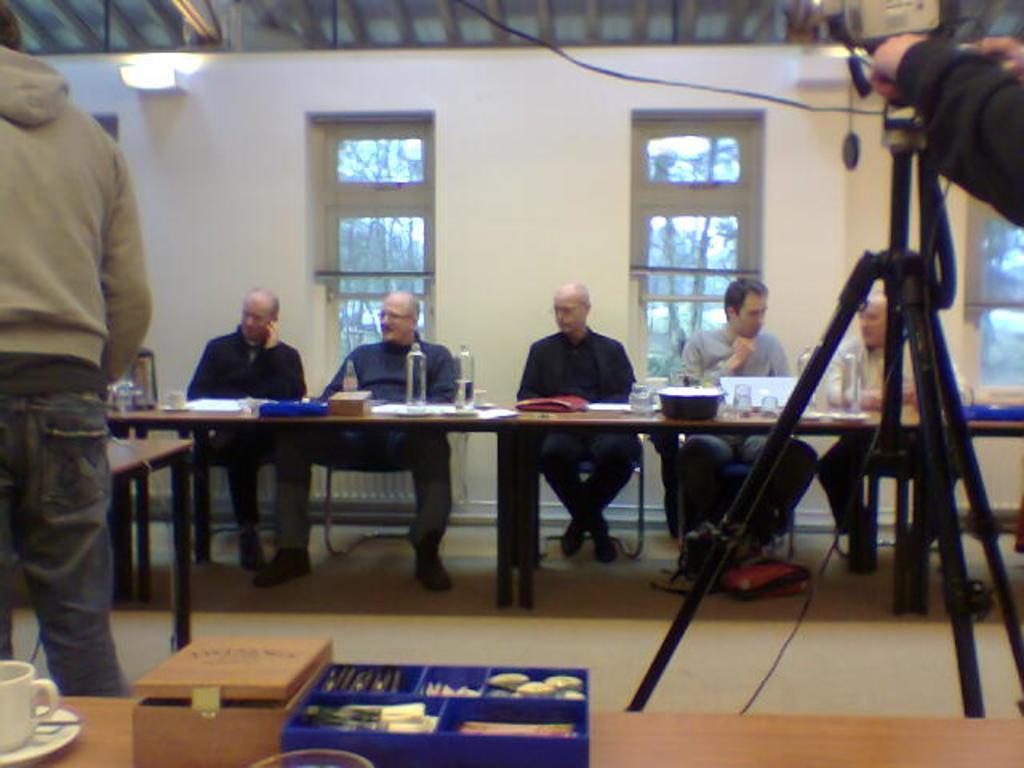Can you describe this image briefly? In the image we can see there are people who are sitting on chair and in front of them there is a table on which water bottle and bowl are kept and at the back there are two windows on the wall and over here the man is standing and he is wearing a jacket. On the table in front we can see there is a wooden box and a cup soccer. 